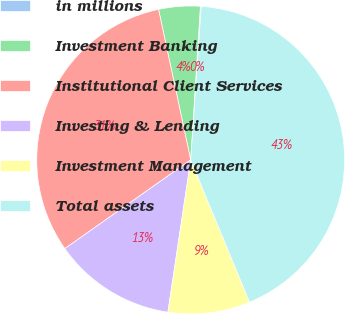<chart> <loc_0><loc_0><loc_500><loc_500><pie_chart><fcel>in millions<fcel>Investment Banking<fcel>Institutional Client Services<fcel>Investing & Lending<fcel>Investment Management<fcel>Total assets<nl><fcel>0.09%<fcel>4.35%<fcel>31.42%<fcel>12.86%<fcel>8.61%<fcel>42.66%<nl></chart> 